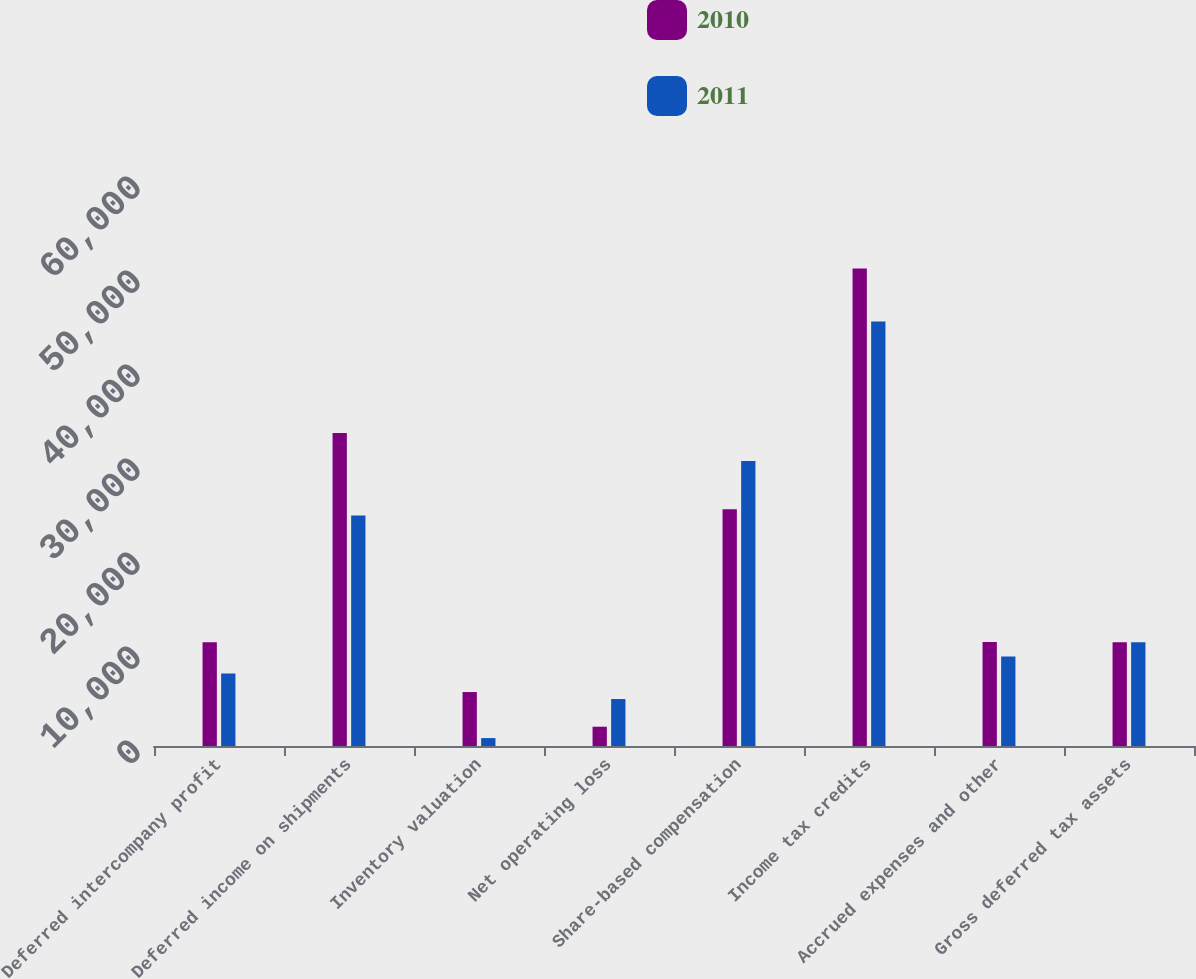Convert chart. <chart><loc_0><loc_0><loc_500><loc_500><stacked_bar_chart><ecel><fcel>Deferred intercompany profit<fcel>Deferred income on shipments<fcel>Inventory valuation<fcel>Net operating loss<fcel>Share-based compensation<fcel>Income tax credits<fcel>Accrued expenses and other<fcel>Gross deferred tax assets<nl><fcel>2010<fcel>11031<fcel>33304<fcel>5740<fcel>2051<fcel>25195<fcel>50795<fcel>11052<fcel>11041.5<nl><fcel>2011<fcel>7711<fcel>24531<fcel>842<fcel>4995<fcel>30316<fcel>45171<fcel>9512<fcel>11041.5<nl></chart> 